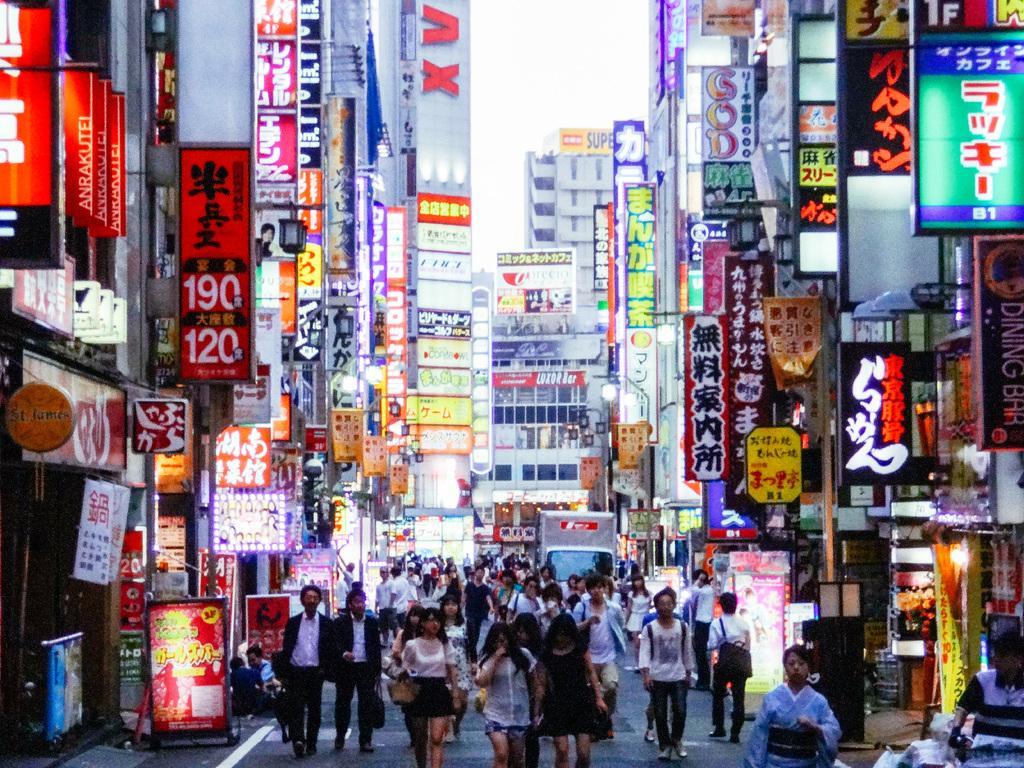Could you give a brief overview of what you see in this image? In this picture I can see there is a street and there are some people walking in the street. There are some buildings here and there buildings are fully covered with banners and the sky is clear. 